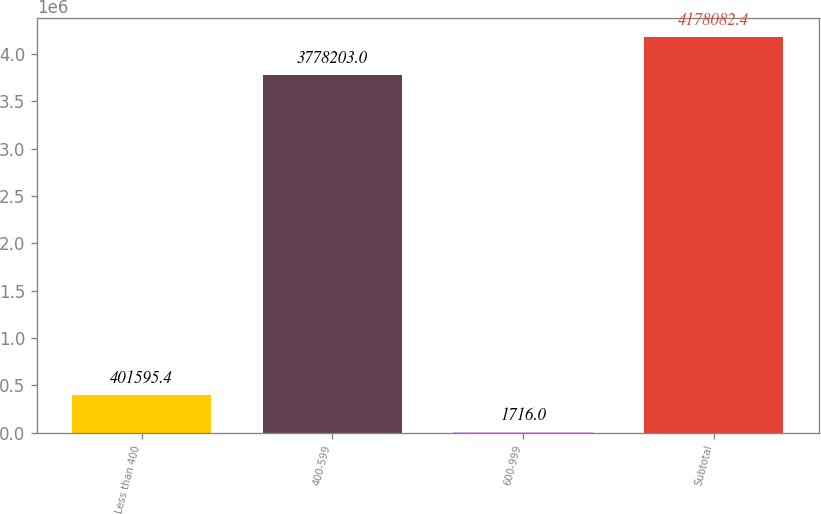Convert chart to OTSL. <chart><loc_0><loc_0><loc_500><loc_500><bar_chart><fcel>Less than 400<fcel>400-599<fcel>600-999<fcel>Subtotal<nl><fcel>401595<fcel>3.7782e+06<fcel>1716<fcel>4.17808e+06<nl></chart> 